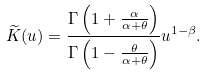Convert formula to latex. <formula><loc_0><loc_0><loc_500><loc_500>\widetilde { K } ( u ) = \frac { \Gamma \left ( 1 + \frac { \alpha } { \alpha + \theta } \right ) } { \Gamma \left ( 1 - \frac { \theta } { \alpha + \theta } \right ) } u ^ { 1 - \beta } .</formula> 